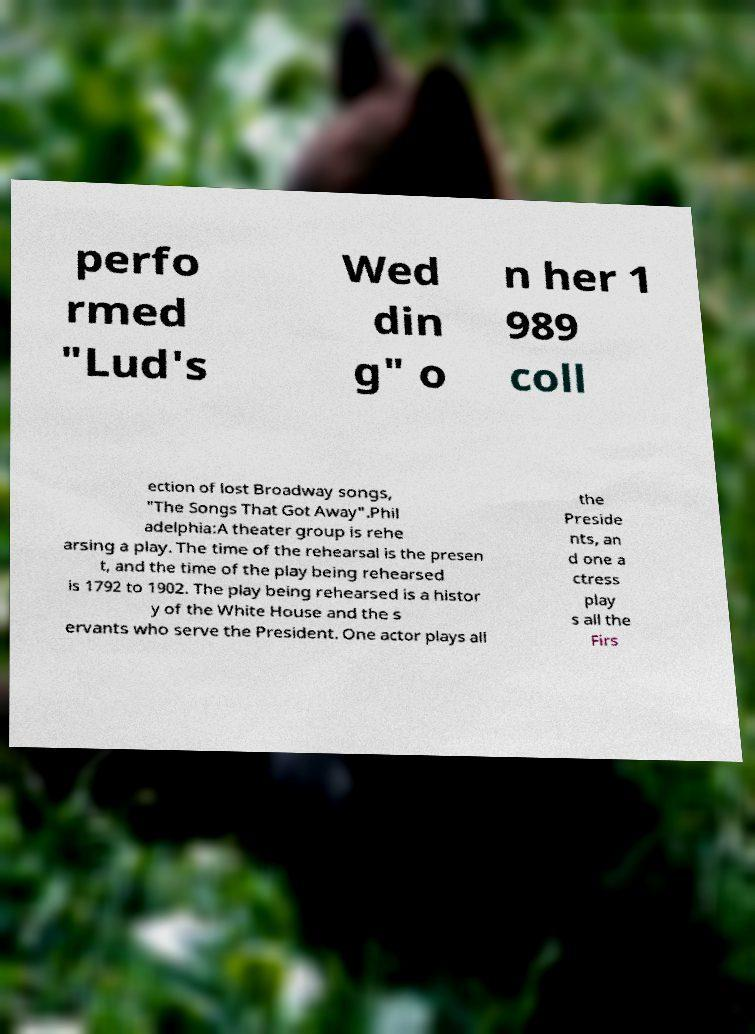I need the written content from this picture converted into text. Can you do that? perfo rmed "Lud's Wed din g" o n her 1 989 coll ection of lost Broadway songs, "The Songs That Got Away".Phil adelphia:A theater group is rehe arsing a play. The time of the rehearsal is the presen t, and the time of the play being rehearsed is 1792 to 1902. The play being rehearsed is a histor y of the White House and the s ervants who serve the President. One actor plays all the Preside nts, an d one a ctress play s all the Firs 